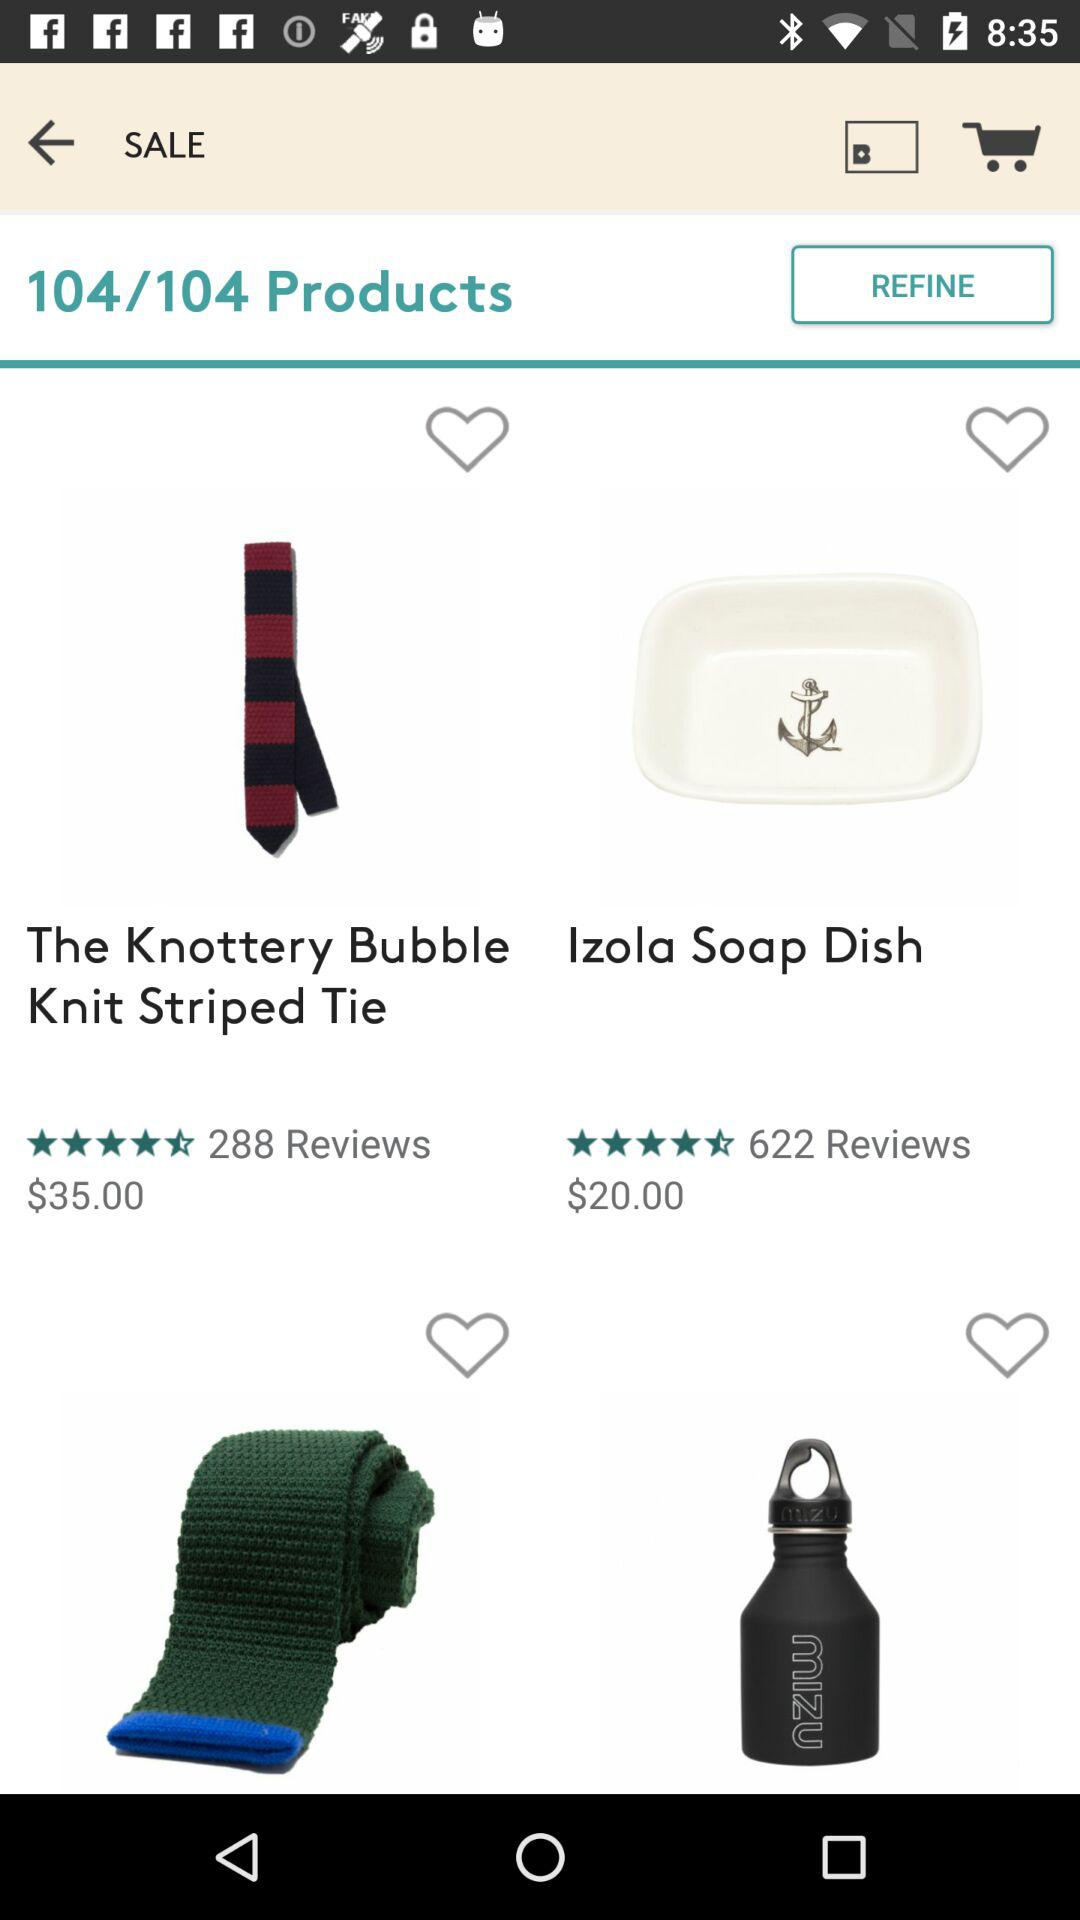Which product has received 288 reviews? The product is "The Knottery Bubble Knit Striped Tie". 